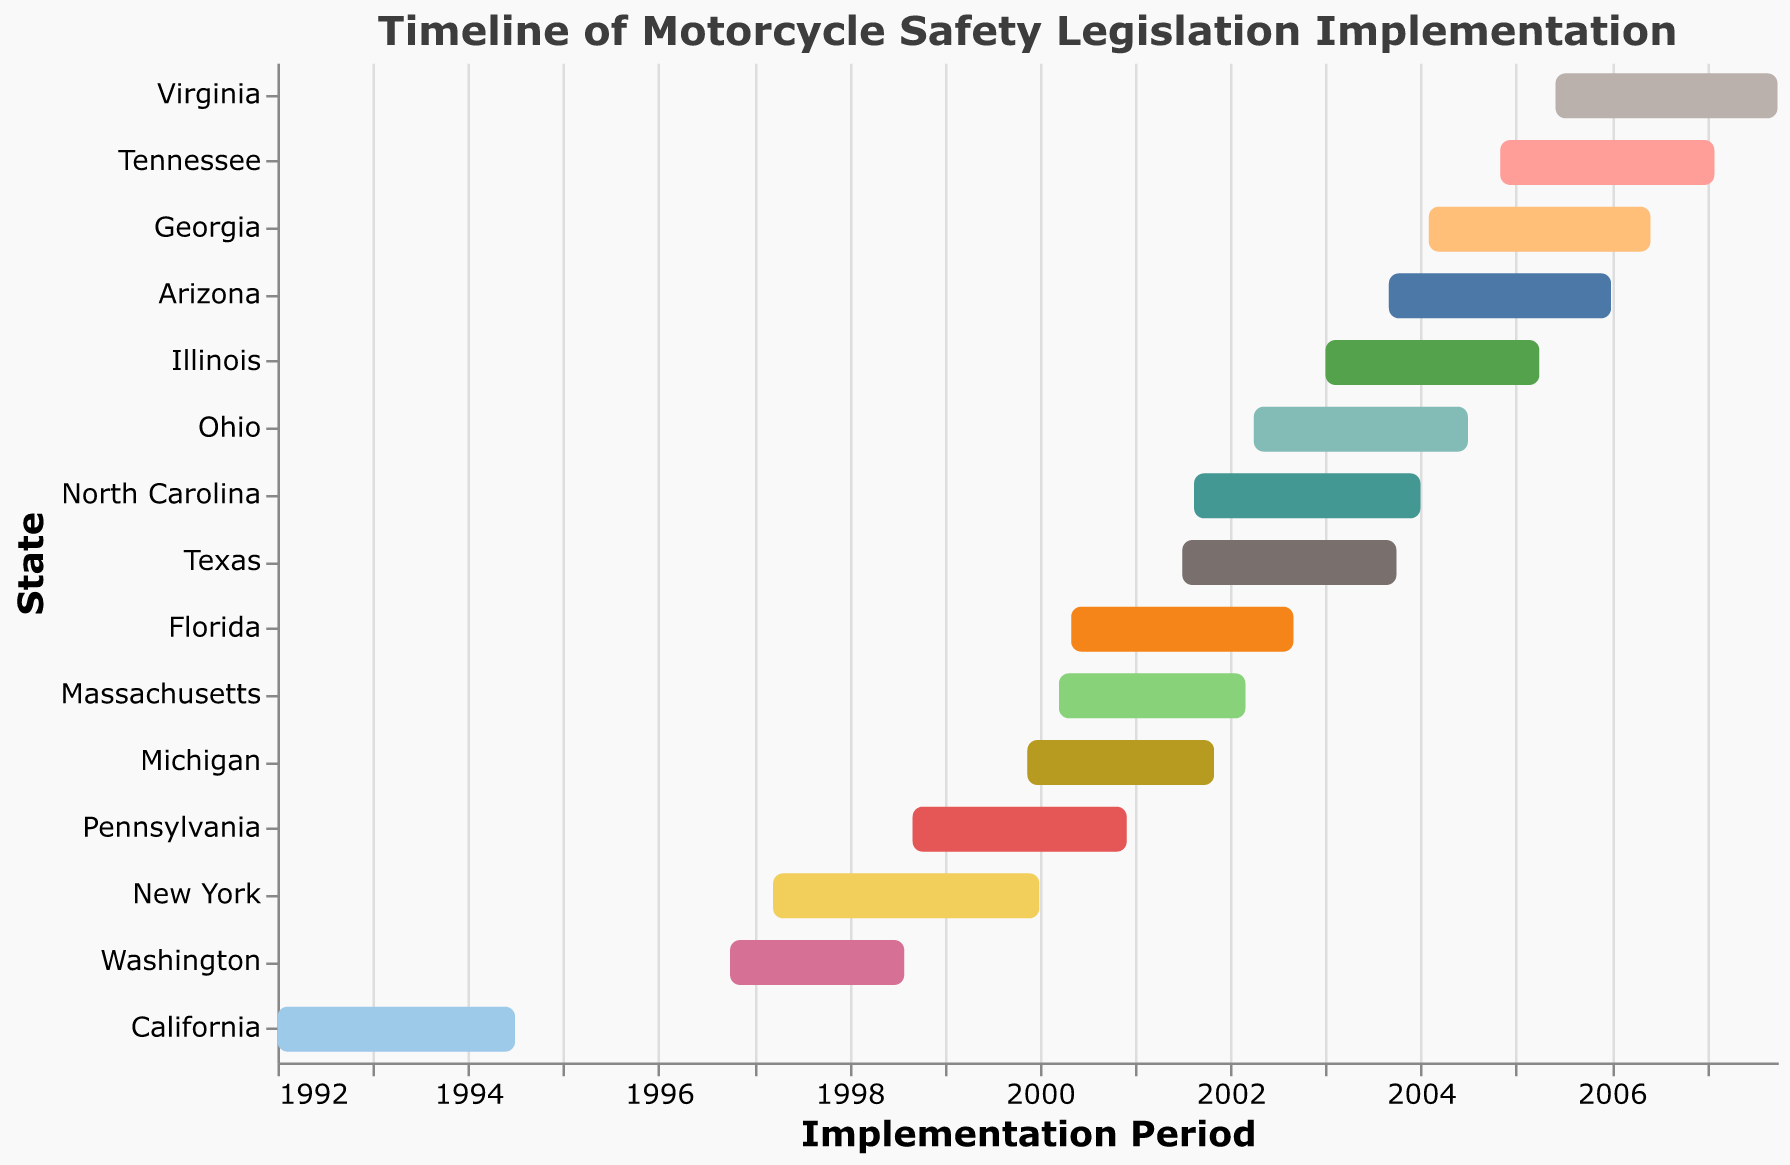Which state started implementing motorcycle safety legislation the earliest? The figure provides the timeline of motorcycle safety legislation implementation for each state. By identifying the earliest start date, we see that California's implementation began on January 1, 1992, which is the earliest.
Answer: California Which state had the longest implementation period? To determine the state with the longest implementation period, we compare the duration from the start date to the end date for each state. Virginia had the longest implementation period from June 1, 2005, to September 30, 2007, which totals 2 years and almost 4 months.
Answer: Virginia How many states implemented motorcycle safety legislation after 2000? To identify the number of states with implementation periods starting after 2000, we count the number of states with start dates beyond January 1, 2000: Texas, Florida, Illinois, Ohio, Georgia, North Carolina, Virginia, Arizona, and Tennessee, totaling 9 states.
Answer: 9 Which states had overlapping implementation periods with Florida? Florida's implementation period is from May 1, 2000, to August 31, 2002. Identifying states with overlapping periods involves checking for intersections with Florida's timeline: Ohio, Michigan, Massachusetts, North Carolina, and Texas had overlapping periods with Florida.
Answer: Ohio, Michigan, Massachusetts, North Carolina, Texas Which state finished its implementation period first? The figure shows the end dates for each state's implementation period. The earliest end date is for California, which finished on June 30, 1994.
Answer: California What is the median start date for the implementation periods across all states? To calculate the median start date, we first list all the start dates in order: January 1, 1992; March 15, 1997; September 1, 1998; November 15, 1999; March 15, 2000; May 1, 2000; August 15, 2001; July 1, 2001; April 1, 2002; February 1, 2004; November 1, 2004; January 1, 2003; September 1, 2003; September 1, 2005. The median start date, being the middle value, is April 1, 2002.
Answer: April 1, 2002 Compare the average duration of implementation periods between states that started before 2000 and those that started after 2000. First, calculate the duration for each state in months. Calculate the average for states starting before 2000: California (30), New York (33), Pennsylvania (27), Michigan (23), Washington (22) gives an average of 27 months. For states starting after 2000: Florida (28), Texas (27), Illinois (27), Ohio (26), North Carolina (28), Arizona (28), Georgia (28), Virginia (28), Tennessee (27) gives an average of 27.5 months.
Answer: Before 2000: 27 months, After 2000: 27.5 months Which states started implementing safety legislation most closely in time? The closest start dates are identified by comparing the dates for all states. Ohio and North Carolina both started their implementations in 2001, with start dates of April 1, 2002, and August 15, 2001, giving a close interval of about 4 months.
Answer: Ohio and North Carolina How many states had an implementation period longer than 3 years? We identify states whose implementation periods exceed 36 months by checking the duration for each. Georgia, Virginia, and Tennessee had periods longer than 3 years.
Answer: 3 Which state had the shortest implementation period? By comparing periods of each state, Pennsylvania's implementation from September 1, 1998, to November 30, 2000, is the shortest at 27 months.
Answer: Pennsylvania 